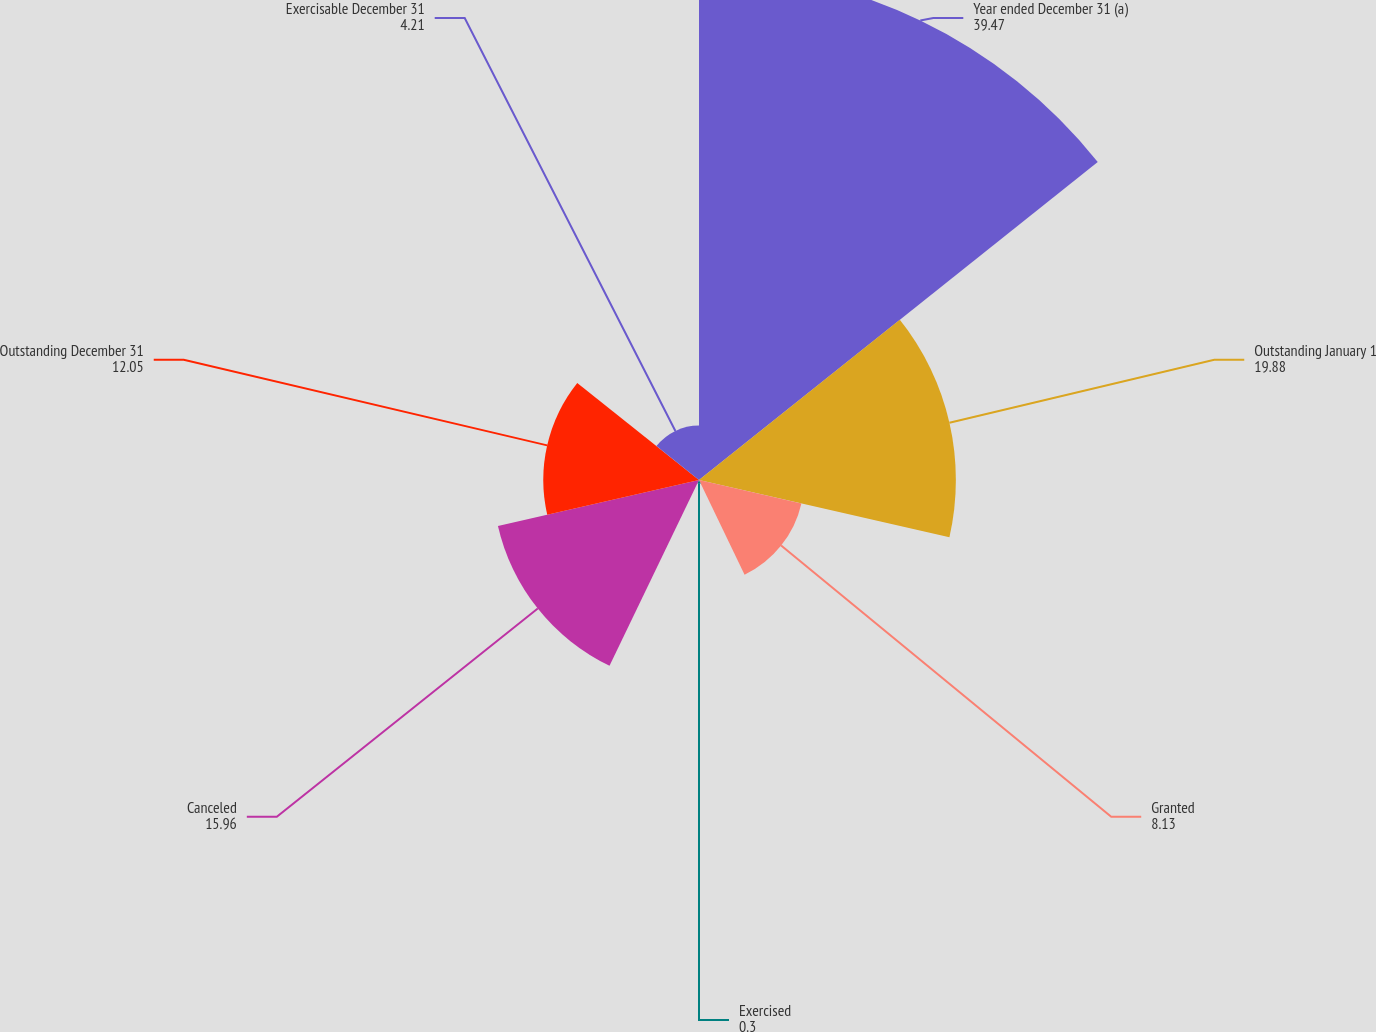Convert chart to OTSL. <chart><loc_0><loc_0><loc_500><loc_500><pie_chart><fcel>Year ended December 31 (a)<fcel>Outstanding January 1<fcel>Granted<fcel>Exercised<fcel>Canceled<fcel>Outstanding December 31<fcel>Exercisable December 31<nl><fcel>39.47%<fcel>19.88%<fcel>8.13%<fcel>0.3%<fcel>15.96%<fcel>12.05%<fcel>4.21%<nl></chart> 